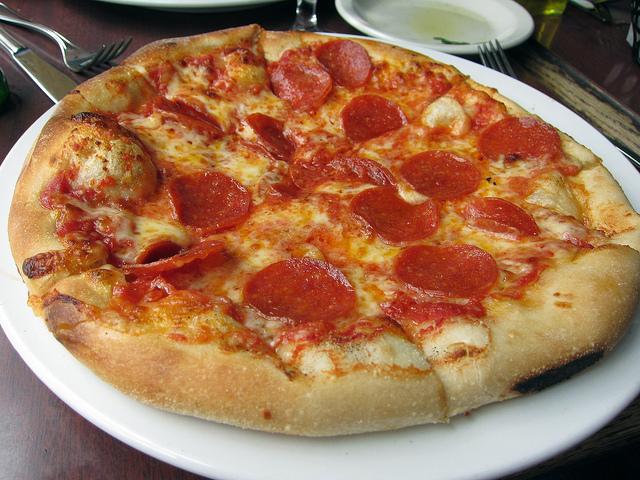What kind of meat is on the pizza?
Write a very short answer. Pepperoni. How many slices do these pizza carrying?
Write a very short answer. 6. What toppings are on the pizza?
Keep it brief. Pepperoni. Does this pizza have a thick crust?
Concise answer only. Yes. Are those jalapenos on the pizza?
Be succinct. No. What color is the plate?
Be succinct. White. 